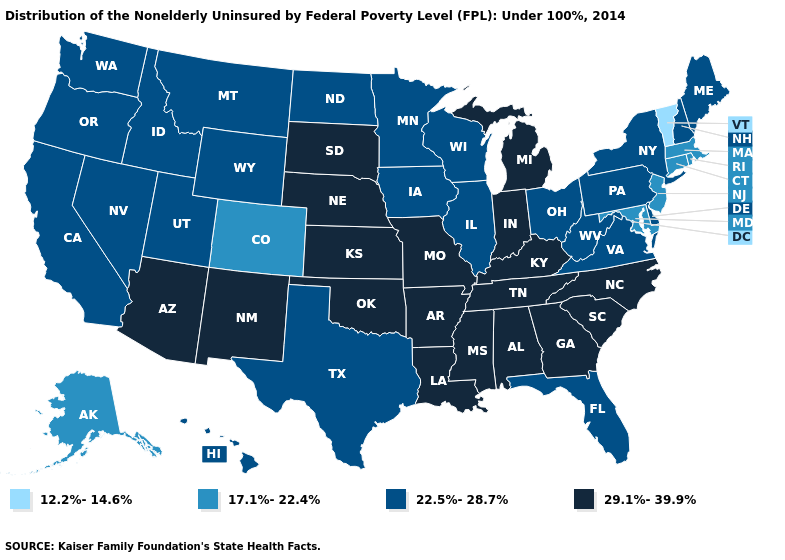Name the states that have a value in the range 12.2%-14.6%?
Write a very short answer. Vermont. Does Vermont have the lowest value in the USA?
Be succinct. Yes. What is the highest value in the USA?
Write a very short answer. 29.1%-39.9%. What is the highest value in the South ?
Be succinct. 29.1%-39.9%. What is the value of Massachusetts?
Answer briefly. 17.1%-22.4%. Name the states that have a value in the range 12.2%-14.6%?
Be succinct. Vermont. What is the value of Montana?
Concise answer only. 22.5%-28.7%. What is the highest value in the USA?
Short answer required. 29.1%-39.9%. Does New Mexico have the lowest value in the West?
Concise answer only. No. What is the value of Virginia?
Concise answer only. 22.5%-28.7%. What is the highest value in the USA?
Be succinct. 29.1%-39.9%. What is the lowest value in the USA?
Keep it brief. 12.2%-14.6%. Name the states that have a value in the range 12.2%-14.6%?
Keep it brief. Vermont. Among the states that border Kentucky , does Indiana have the lowest value?
Quick response, please. No. 